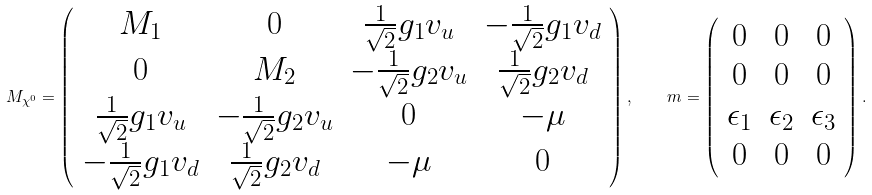<formula> <loc_0><loc_0><loc_500><loc_500>M _ { \chi ^ { 0 } } = \left ( \begin{array} { c c c c } M _ { 1 } & 0 & \frac { 1 } { \sqrt { 2 } } g _ { 1 } v _ { u } & - \frac { 1 } { \sqrt { 2 } } g _ { 1 } v _ { d } \\ 0 & M _ { 2 } & - \frac { 1 } { \sqrt { 2 } } g _ { 2 } v _ { u } & \frac { 1 } { \sqrt { 2 } } g _ { 2 } v _ { d } \\ \frac { 1 } { \sqrt { 2 } } g _ { 1 } v _ { u } & - \frac { 1 } { \sqrt { 2 } } g _ { 2 } v _ { u } & 0 & - \mu \\ - \frac { 1 } { \sqrt { 2 } } g _ { 1 } v _ { d } & \frac { 1 } { \sqrt { 2 } } g _ { 2 } v _ { d } & - \mu & 0 \end{array} \right ) , \quad m = \left ( \begin{array} { c c c } 0 & 0 & 0 \\ 0 & 0 & 0 \\ \epsilon _ { 1 } & \epsilon _ { 2 } & \epsilon _ { 3 } \\ 0 & 0 & 0 \end{array} \right ) .</formula> 